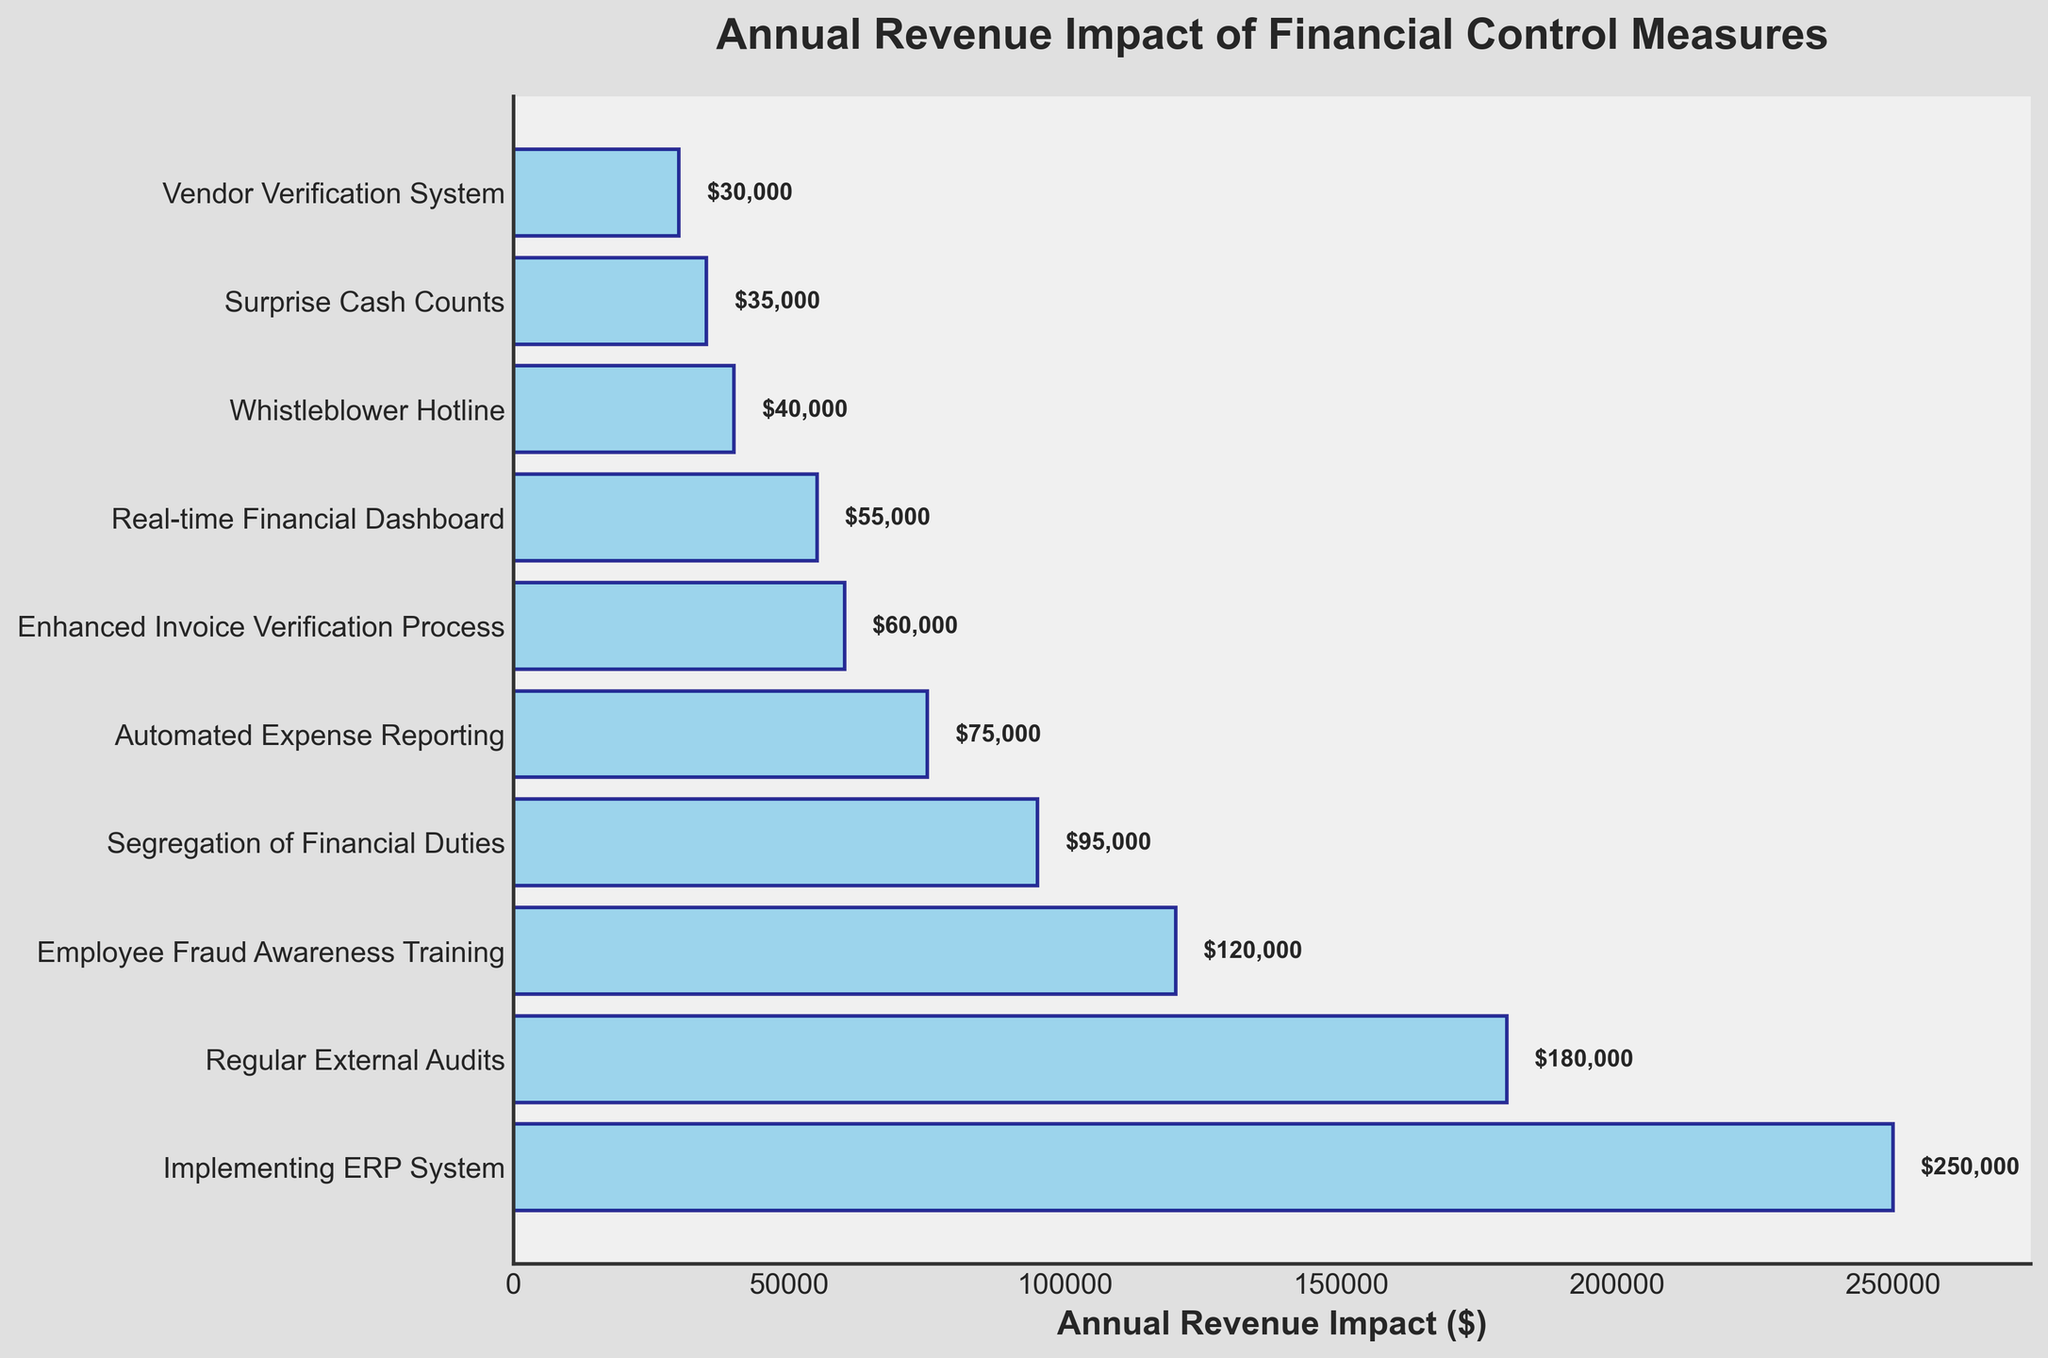What's the measure with the highest annual revenue impact? The bar corresponding to "Implementing ERP System" extends the farthest to the right, indicating the highest revenue impact.
Answer: Implementing ERP System What's the difference in annual revenue impact between "Implementing ERP System" and "Regular External Audits"? The annual revenue impact of "Implementing ERP System" is $250,000 and for "Regular External Audits" is $180,000. The difference is $250,000 - $180,000.
Answer: $70,000 Which measure has a lower annual revenue impact: "Employee Fraud Awareness Training" or "Automated Expense Reporting"? Comparing the lengths of the bars, "Automated Expense Reporting" at $75,000 is shorter compared to "Employee Fraud Awareness Training" at $120,000.
Answer: Automated Expense Reporting What is the average annual revenue impact of the top three measures? The impacts of the top three measures are: Implementing ERP System ($250,000), Regular External Audits ($180,000), and Employee Fraud Awareness Training ($120,000). The average is calculated as (250,000 + 180,000 + 120,000) / 3.
Answer: $183,333.33 What's the combined annual revenue impact of "Segregation of Financial Duties" and "Vendor Verification System"? Adding the impacts of both measures: $95,000 + $30,000.
Answer: $125,000 How much more revenue impact does "Enhanced Invoice Verification Process" have compared to "Whistleblower Hotline"? The impact of "Enhanced Invoice Verification Process" is $60,000 and "Whistleblower Hotline" is $40,000. The difference is $60,000 - $40,000.
Answer: $20,000 What measures have an annual revenue impact greater than $50,000 but less than $100,000? The measures within this range are "Segregation of Financial Duties" ($95,000), "Automated Expense Reporting" ($75,000), and "Enhanced Invoice Verification Process" ($60,000).
Answer: Segregation of Financial Duties, Automated Expense Reporting, Enhanced Invoice Verification Process Which measure contributes the least to the annual revenue impact? The shortest bar is for "Vendor Verification System," which shows the lowest impact of $30,000.
Answer: Vendor Verification System What is the total combined annual revenue impact of all measures? Sum of all impacts: 250,000 + 180,000 + 120,000 + 95,000 + 75,000 + 60,000 + 55,000 + 40,000 + 35,000 + 30,000.
Answer: $940,000 